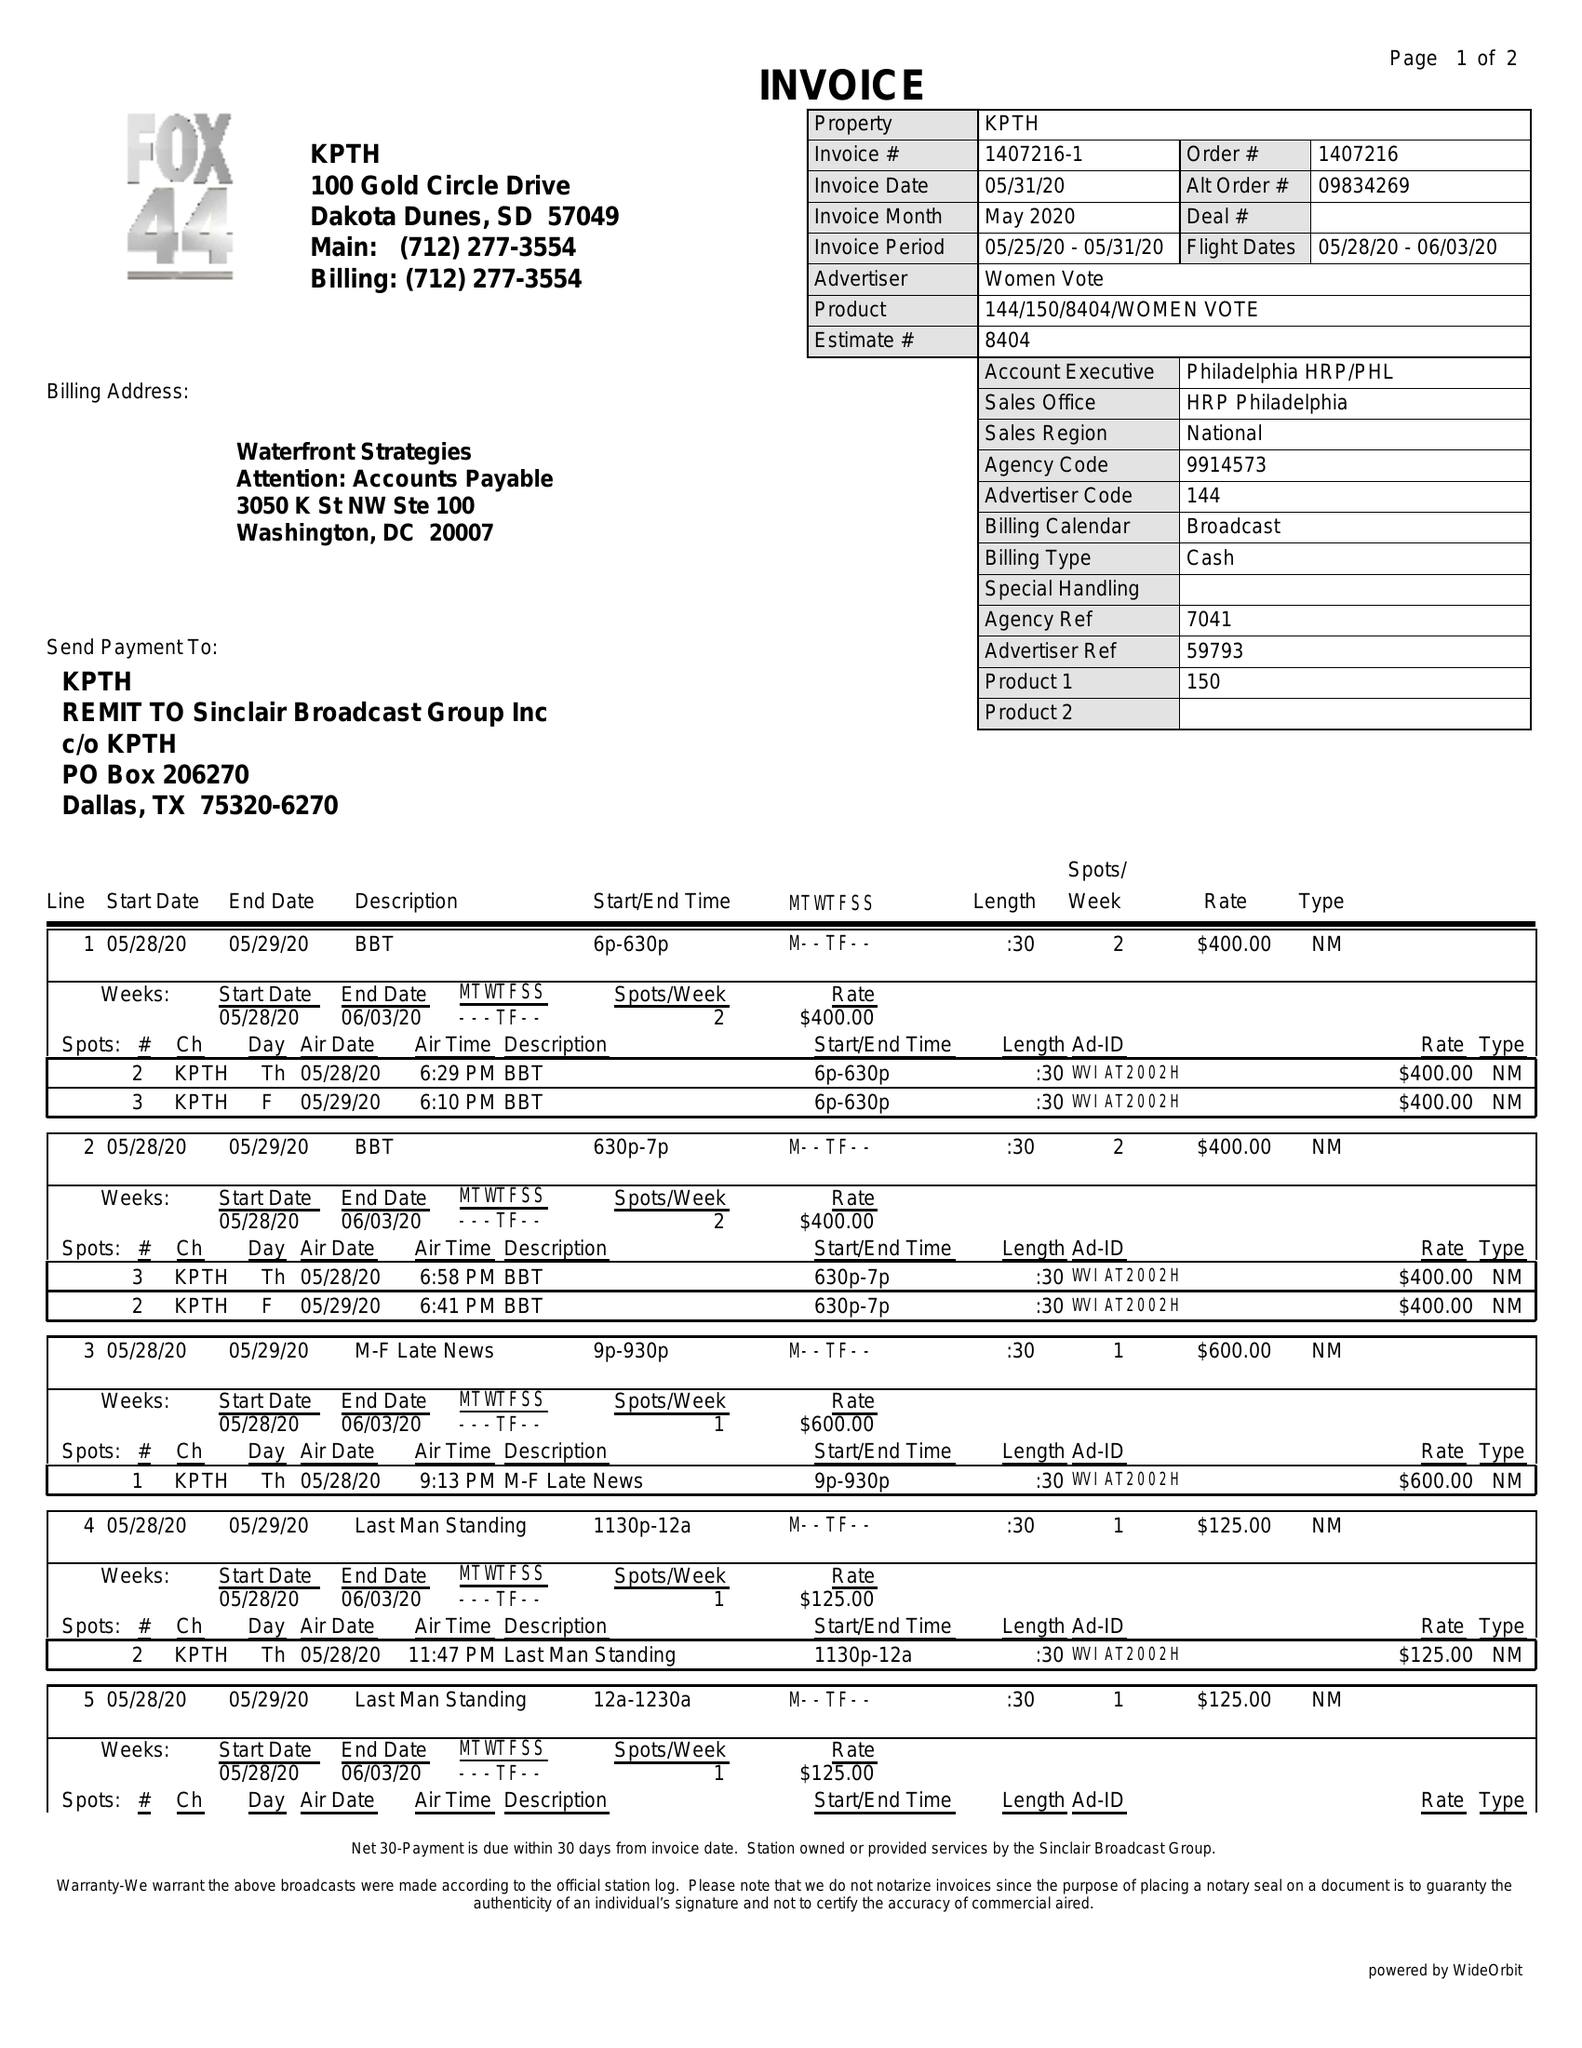What is the value for the flight_to?
Answer the question using a single word or phrase. 06/03/20 